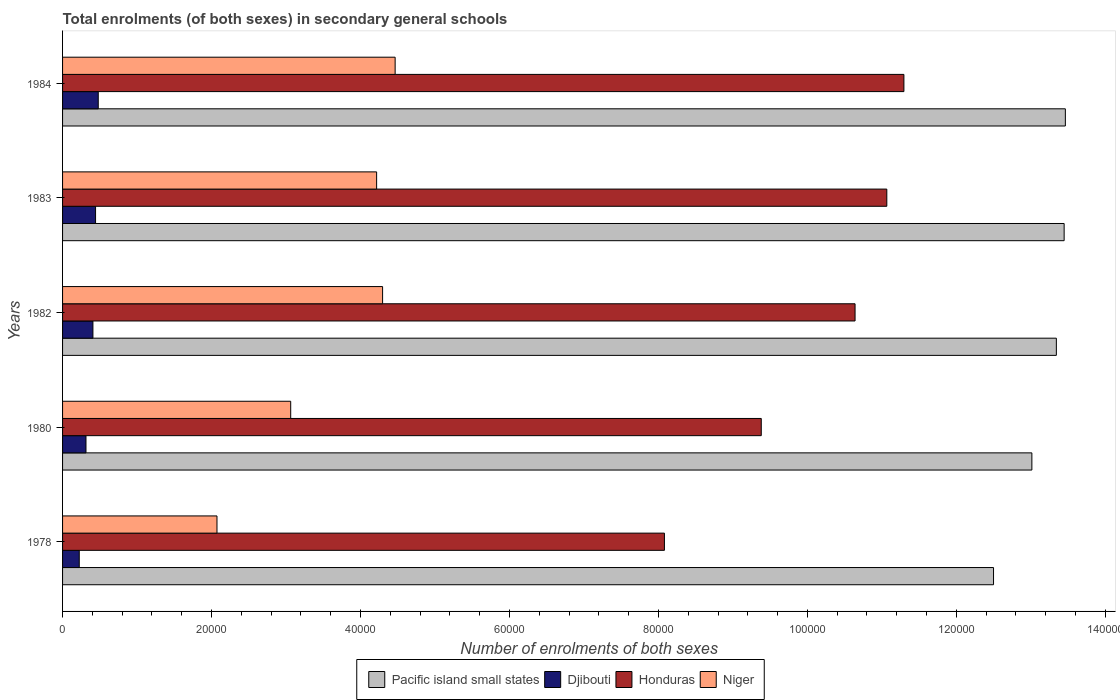How many groups of bars are there?
Provide a short and direct response. 5. What is the label of the 3rd group of bars from the top?
Offer a terse response. 1982. What is the number of enrolments in secondary schools in Niger in 1982?
Your answer should be compact. 4.30e+04. Across all years, what is the maximum number of enrolments in secondary schools in Pacific island small states?
Keep it short and to the point. 1.35e+05. Across all years, what is the minimum number of enrolments in secondary schools in Niger?
Keep it short and to the point. 2.07e+04. In which year was the number of enrolments in secondary schools in Djibouti maximum?
Keep it short and to the point. 1984. In which year was the number of enrolments in secondary schools in Pacific island small states minimum?
Make the answer very short. 1978. What is the total number of enrolments in secondary schools in Pacific island small states in the graph?
Your answer should be very brief. 6.58e+05. What is the difference between the number of enrolments in secondary schools in Niger in 1980 and that in 1984?
Offer a terse response. -1.40e+04. What is the difference between the number of enrolments in secondary schools in Pacific island small states in 1982 and the number of enrolments in secondary schools in Honduras in 1984?
Make the answer very short. 2.05e+04. What is the average number of enrolments in secondary schools in Honduras per year?
Provide a short and direct response. 1.01e+05. In the year 1978, what is the difference between the number of enrolments in secondary schools in Djibouti and number of enrolments in secondary schools in Niger?
Your response must be concise. -1.85e+04. In how many years, is the number of enrolments in secondary schools in Honduras greater than 40000 ?
Offer a very short reply. 5. What is the ratio of the number of enrolments in secondary schools in Djibouti in 1978 to that in 1980?
Ensure brevity in your answer.  0.71. Is the number of enrolments in secondary schools in Djibouti in 1978 less than that in 1984?
Ensure brevity in your answer.  Yes. What is the difference between the highest and the second highest number of enrolments in secondary schools in Djibouti?
Offer a terse response. 362. What is the difference between the highest and the lowest number of enrolments in secondary schools in Djibouti?
Give a very brief answer. 2551. In how many years, is the number of enrolments in secondary schools in Niger greater than the average number of enrolments in secondary schools in Niger taken over all years?
Give a very brief answer. 3. Is it the case that in every year, the sum of the number of enrolments in secondary schools in Djibouti and number of enrolments in secondary schools in Niger is greater than the sum of number of enrolments in secondary schools in Pacific island small states and number of enrolments in secondary schools in Honduras?
Your answer should be very brief. No. What does the 4th bar from the top in 1978 represents?
Provide a short and direct response. Pacific island small states. What does the 3rd bar from the bottom in 1978 represents?
Offer a terse response. Honduras. Is it the case that in every year, the sum of the number of enrolments in secondary schools in Honduras and number of enrolments in secondary schools in Pacific island small states is greater than the number of enrolments in secondary schools in Djibouti?
Provide a short and direct response. Yes. How many years are there in the graph?
Ensure brevity in your answer.  5. What is the difference between two consecutive major ticks on the X-axis?
Keep it short and to the point. 2.00e+04. Are the values on the major ticks of X-axis written in scientific E-notation?
Keep it short and to the point. No. Does the graph contain grids?
Your answer should be compact. No. Where does the legend appear in the graph?
Provide a short and direct response. Bottom center. How many legend labels are there?
Provide a short and direct response. 4. How are the legend labels stacked?
Your answer should be very brief. Horizontal. What is the title of the graph?
Your answer should be very brief. Total enrolments (of both sexes) in secondary general schools. What is the label or title of the X-axis?
Keep it short and to the point. Number of enrolments of both sexes. What is the label or title of the Y-axis?
Make the answer very short. Years. What is the Number of enrolments of both sexes of Pacific island small states in 1978?
Your answer should be very brief. 1.25e+05. What is the Number of enrolments of both sexes in Djibouti in 1978?
Ensure brevity in your answer.  2240. What is the Number of enrolments of both sexes of Honduras in 1978?
Your answer should be compact. 8.08e+04. What is the Number of enrolments of both sexes of Niger in 1978?
Offer a very short reply. 2.07e+04. What is the Number of enrolments of both sexes of Pacific island small states in 1980?
Keep it short and to the point. 1.30e+05. What is the Number of enrolments of both sexes of Djibouti in 1980?
Your answer should be very brief. 3144. What is the Number of enrolments of both sexes in Honduras in 1980?
Provide a succinct answer. 9.38e+04. What is the Number of enrolments of both sexes in Niger in 1980?
Your answer should be very brief. 3.06e+04. What is the Number of enrolments of both sexes of Pacific island small states in 1982?
Your answer should be very brief. 1.33e+05. What is the Number of enrolments of both sexes of Djibouti in 1982?
Offer a terse response. 4076. What is the Number of enrolments of both sexes in Honduras in 1982?
Your response must be concise. 1.06e+05. What is the Number of enrolments of both sexes in Niger in 1982?
Offer a terse response. 4.30e+04. What is the Number of enrolments of both sexes of Pacific island small states in 1983?
Make the answer very short. 1.34e+05. What is the Number of enrolments of both sexes of Djibouti in 1983?
Ensure brevity in your answer.  4429. What is the Number of enrolments of both sexes of Honduras in 1983?
Offer a terse response. 1.11e+05. What is the Number of enrolments of both sexes in Niger in 1983?
Your response must be concise. 4.22e+04. What is the Number of enrolments of both sexes in Pacific island small states in 1984?
Give a very brief answer. 1.35e+05. What is the Number of enrolments of both sexes of Djibouti in 1984?
Your answer should be very brief. 4791. What is the Number of enrolments of both sexes in Honduras in 1984?
Your answer should be compact. 1.13e+05. What is the Number of enrolments of both sexes in Niger in 1984?
Your answer should be compact. 4.46e+04. Across all years, what is the maximum Number of enrolments of both sexes of Pacific island small states?
Keep it short and to the point. 1.35e+05. Across all years, what is the maximum Number of enrolments of both sexes in Djibouti?
Your answer should be very brief. 4791. Across all years, what is the maximum Number of enrolments of both sexes in Honduras?
Provide a succinct answer. 1.13e+05. Across all years, what is the maximum Number of enrolments of both sexes in Niger?
Give a very brief answer. 4.46e+04. Across all years, what is the minimum Number of enrolments of both sexes in Pacific island small states?
Your response must be concise. 1.25e+05. Across all years, what is the minimum Number of enrolments of both sexes of Djibouti?
Provide a short and direct response. 2240. Across all years, what is the minimum Number of enrolments of both sexes in Honduras?
Ensure brevity in your answer.  8.08e+04. Across all years, what is the minimum Number of enrolments of both sexes in Niger?
Your answer should be very brief. 2.07e+04. What is the total Number of enrolments of both sexes of Pacific island small states in the graph?
Make the answer very short. 6.58e+05. What is the total Number of enrolments of both sexes of Djibouti in the graph?
Your answer should be very brief. 1.87e+04. What is the total Number of enrolments of both sexes in Honduras in the graph?
Provide a short and direct response. 5.05e+05. What is the total Number of enrolments of both sexes of Niger in the graph?
Provide a short and direct response. 1.81e+05. What is the difference between the Number of enrolments of both sexes in Pacific island small states in 1978 and that in 1980?
Offer a terse response. -5147.85. What is the difference between the Number of enrolments of both sexes of Djibouti in 1978 and that in 1980?
Your answer should be compact. -904. What is the difference between the Number of enrolments of both sexes of Honduras in 1978 and that in 1980?
Make the answer very short. -1.30e+04. What is the difference between the Number of enrolments of both sexes of Niger in 1978 and that in 1980?
Provide a short and direct response. -9898. What is the difference between the Number of enrolments of both sexes in Pacific island small states in 1978 and that in 1982?
Provide a succinct answer. -8435.27. What is the difference between the Number of enrolments of both sexes of Djibouti in 1978 and that in 1982?
Give a very brief answer. -1836. What is the difference between the Number of enrolments of both sexes of Honduras in 1978 and that in 1982?
Your answer should be compact. -2.56e+04. What is the difference between the Number of enrolments of both sexes of Niger in 1978 and that in 1982?
Keep it short and to the point. -2.22e+04. What is the difference between the Number of enrolments of both sexes in Pacific island small states in 1978 and that in 1983?
Provide a short and direct response. -9479.97. What is the difference between the Number of enrolments of both sexes of Djibouti in 1978 and that in 1983?
Provide a short and direct response. -2189. What is the difference between the Number of enrolments of both sexes of Honduras in 1978 and that in 1983?
Keep it short and to the point. -2.99e+04. What is the difference between the Number of enrolments of both sexes in Niger in 1978 and that in 1983?
Provide a short and direct response. -2.14e+04. What is the difference between the Number of enrolments of both sexes of Pacific island small states in 1978 and that in 1984?
Keep it short and to the point. -9641.75. What is the difference between the Number of enrolments of both sexes of Djibouti in 1978 and that in 1984?
Provide a succinct answer. -2551. What is the difference between the Number of enrolments of both sexes in Honduras in 1978 and that in 1984?
Your answer should be compact. -3.22e+04. What is the difference between the Number of enrolments of both sexes in Niger in 1978 and that in 1984?
Provide a succinct answer. -2.39e+04. What is the difference between the Number of enrolments of both sexes of Pacific island small states in 1980 and that in 1982?
Keep it short and to the point. -3287.41. What is the difference between the Number of enrolments of both sexes of Djibouti in 1980 and that in 1982?
Offer a terse response. -932. What is the difference between the Number of enrolments of both sexes of Honduras in 1980 and that in 1982?
Make the answer very short. -1.26e+04. What is the difference between the Number of enrolments of both sexes in Niger in 1980 and that in 1982?
Make the answer very short. -1.23e+04. What is the difference between the Number of enrolments of both sexes of Pacific island small states in 1980 and that in 1983?
Your response must be concise. -4332.12. What is the difference between the Number of enrolments of both sexes of Djibouti in 1980 and that in 1983?
Offer a terse response. -1285. What is the difference between the Number of enrolments of both sexes in Honduras in 1980 and that in 1983?
Ensure brevity in your answer.  -1.69e+04. What is the difference between the Number of enrolments of both sexes in Niger in 1980 and that in 1983?
Ensure brevity in your answer.  -1.15e+04. What is the difference between the Number of enrolments of both sexes of Pacific island small states in 1980 and that in 1984?
Keep it short and to the point. -4493.9. What is the difference between the Number of enrolments of both sexes of Djibouti in 1980 and that in 1984?
Offer a very short reply. -1647. What is the difference between the Number of enrolments of both sexes of Honduras in 1980 and that in 1984?
Provide a short and direct response. -1.92e+04. What is the difference between the Number of enrolments of both sexes of Niger in 1980 and that in 1984?
Keep it short and to the point. -1.40e+04. What is the difference between the Number of enrolments of both sexes of Pacific island small states in 1982 and that in 1983?
Provide a succinct answer. -1044.7. What is the difference between the Number of enrolments of both sexes of Djibouti in 1982 and that in 1983?
Your answer should be compact. -353. What is the difference between the Number of enrolments of both sexes of Honduras in 1982 and that in 1983?
Your answer should be compact. -4263. What is the difference between the Number of enrolments of both sexes in Niger in 1982 and that in 1983?
Keep it short and to the point. 803. What is the difference between the Number of enrolments of both sexes of Pacific island small states in 1982 and that in 1984?
Provide a succinct answer. -1206.48. What is the difference between the Number of enrolments of both sexes in Djibouti in 1982 and that in 1984?
Provide a short and direct response. -715. What is the difference between the Number of enrolments of both sexes in Honduras in 1982 and that in 1984?
Give a very brief answer. -6558. What is the difference between the Number of enrolments of both sexes in Niger in 1982 and that in 1984?
Offer a very short reply. -1683. What is the difference between the Number of enrolments of both sexes of Pacific island small states in 1983 and that in 1984?
Provide a succinct answer. -161.78. What is the difference between the Number of enrolments of both sexes in Djibouti in 1983 and that in 1984?
Your answer should be compact. -362. What is the difference between the Number of enrolments of both sexes of Honduras in 1983 and that in 1984?
Provide a succinct answer. -2295. What is the difference between the Number of enrolments of both sexes in Niger in 1983 and that in 1984?
Offer a very short reply. -2486. What is the difference between the Number of enrolments of both sexes in Pacific island small states in 1978 and the Number of enrolments of both sexes in Djibouti in 1980?
Your response must be concise. 1.22e+05. What is the difference between the Number of enrolments of both sexes of Pacific island small states in 1978 and the Number of enrolments of both sexes of Honduras in 1980?
Your answer should be compact. 3.12e+04. What is the difference between the Number of enrolments of both sexes in Pacific island small states in 1978 and the Number of enrolments of both sexes in Niger in 1980?
Provide a short and direct response. 9.44e+04. What is the difference between the Number of enrolments of both sexes of Djibouti in 1978 and the Number of enrolments of both sexes of Honduras in 1980?
Offer a terse response. -9.16e+04. What is the difference between the Number of enrolments of both sexes of Djibouti in 1978 and the Number of enrolments of both sexes of Niger in 1980?
Offer a very short reply. -2.84e+04. What is the difference between the Number of enrolments of both sexes of Honduras in 1978 and the Number of enrolments of both sexes of Niger in 1980?
Your answer should be very brief. 5.02e+04. What is the difference between the Number of enrolments of both sexes in Pacific island small states in 1978 and the Number of enrolments of both sexes in Djibouti in 1982?
Your answer should be compact. 1.21e+05. What is the difference between the Number of enrolments of both sexes of Pacific island small states in 1978 and the Number of enrolments of both sexes of Honduras in 1982?
Provide a succinct answer. 1.86e+04. What is the difference between the Number of enrolments of both sexes in Pacific island small states in 1978 and the Number of enrolments of both sexes in Niger in 1982?
Your answer should be very brief. 8.20e+04. What is the difference between the Number of enrolments of both sexes of Djibouti in 1978 and the Number of enrolments of both sexes of Honduras in 1982?
Your response must be concise. -1.04e+05. What is the difference between the Number of enrolments of both sexes of Djibouti in 1978 and the Number of enrolments of both sexes of Niger in 1982?
Make the answer very short. -4.07e+04. What is the difference between the Number of enrolments of both sexes in Honduras in 1978 and the Number of enrolments of both sexes in Niger in 1982?
Ensure brevity in your answer.  3.78e+04. What is the difference between the Number of enrolments of both sexes in Pacific island small states in 1978 and the Number of enrolments of both sexes in Djibouti in 1983?
Ensure brevity in your answer.  1.21e+05. What is the difference between the Number of enrolments of both sexes in Pacific island small states in 1978 and the Number of enrolments of both sexes in Honduras in 1983?
Your answer should be compact. 1.43e+04. What is the difference between the Number of enrolments of both sexes in Pacific island small states in 1978 and the Number of enrolments of both sexes in Niger in 1983?
Ensure brevity in your answer.  8.28e+04. What is the difference between the Number of enrolments of both sexes of Djibouti in 1978 and the Number of enrolments of both sexes of Honduras in 1983?
Give a very brief answer. -1.08e+05. What is the difference between the Number of enrolments of both sexes of Djibouti in 1978 and the Number of enrolments of both sexes of Niger in 1983?
Give a very brief answer. -3.99e+04. What is the difference between the Number of enrolments of both sexes of Honduras in 1978 and the Number of enrolments of both sexes of Niger in 1983?
Your answer should be very brief. 3.86e+04. What is the difference between the Number of enrolments of both sexes in Pacific island small states in 1978 and the Number of enrolments of both sexes in Djibouti in 1984?
Your answer should be very brief. 1.20e+05. What is the difference between the Number of enrolments of both sexes of Pacific island small states in 1978 and the Number of enrolments of both sexes of Honduras in 1984?
Ensure brevity in your answer.  1.20e+04. What is the difference between the Number of enrolments of both sexes in Pacific island small states in 1978 and the Number of enrolments of both sexes in Niger in 1984?
Ensure brevity in your answer.  8.03e+04. What is the difference between the Number of enrolments of both sexes in Djibouti in 1978 and the Number of enrolments of both sexes in Honduras in 1984?
Offer a terse response. -1.11e+05. What is the difference between the Number of enrolments of both sexes in Djibouti in 1978 and the Number of enrolments of both sexes in Niger in 1984?
Keep it short and to the point. -4.24e+04. What is the difference between the Number of enrolments of both sexes in Honduras in 1978 and the Number of enrolments of both sexes in Niger in 1984?
Offer a terse response. 3.62e+04. What is the difference between the Number of enrolments of both sexes in Pacific island small states in 1980 and the Number of enrolments of both sexes in Djibouti in 1982?
Provide a short and direct response. 1.26e+05. What is the difference between the Number of enrolments of both sexes of Pacific island small states in 1980 and the Number of enrolments of both sexes of Honduras in 1982?
Keep it short and to the point. 2.37e+04. What is the difference between the Number of enrolments of both sexes of Pacific island small states in 1980 and the Number of enrolments of both sexes of Niger in 1982?
Ensure brevity in your answer.  8.72e+04. What is the difference between the Number of enrolments of both sexes of Djibouti in 1980 and the Number of enrolments of both sexes of Honduras in 1982?
Keep it short and to the point. -1.03e+05. What is the difference between the Number of enrolments of both sexes in Djibouti in 1980 and the Number of enrolments of both sexes in Niger in 1982?
Give a very brief answer. -3.98e+04. What is the difference between the Number of enrolments of both sexes of Honduras in 1980 and the Number of enrolments of both sexes of Niger in 1982?
Provide a short and direct response. 5.08e+04. What is the difference between the Number of enrolments of both sexes of Pacific island small states in 1980 and the Number of enrolments of both sexes of Djibouti in 1983?
Your answer should be very brief. 1.26e+05. What is the difference between the Number of enrolments of both sexes in Pacific island small states in 1980 and the Number of enrolments of both sexes in Honduras in 1983?
Your response must be concise. 1.95e+04. What is the difference between the Number of enrolments of both sexes in Pacific island small states in 1980 and the Number of enrolments of both sexes in Niger in 1983?
Give a very brief answer. 8.80e+04. What is the difference between the Number of enrolments of both sexes in Djibouti in 1980 and the Number of enrolments of both sexes in Honduras in 1983?
Your answer should be compact. -1.08e+05. What is the difference between the Number of enrolments of both sexes of Djibouti in 1980 and the Number of enrolments of both sexes of Niger in 1983?
Offer a terse response. -3.90e+04. What is the difference between the Number of enrolments of both sexes in Honduras in 1980 and the Number of enrolments of both sexes in Niger in 1983?
Make the answer very short. 5.16e+04. What is the difference between the Number of enrolments of both sexes in Pacific island small states in 1980 and the Number of enrolments of both sexes in Djibouti in 1984?
Offer a terse response. 1.25e+05. What is the difference between the Number of enrolments of both sexes of Pacific island small states in 1980 and the Number of enrolments of both sexes of Honduras in 1984?
Ensure brevity in your answer.  1.72e+04. What is the difference between the Number of enrolments of both sexes in Pacific island small states in 1980 and the Number of enrolments of both sexes in Niger in 1984?
Offer a terse response. 8.55e+04. What is the difference between the Number of enrolments of both sexes in Djibouti in 1980 and the Number of enrolments of both sexes in Honduras in 1984?
Provide a succinct answer. -1.10e+05. What is the difference between the Number of enrolments of both sexes in Djibouti in 1980 and the Number of enrolments of both sexes in Niger in 1984?
Offer a terse response. -4.15e+04. What is the difference between the Number of enrolments of both sexes in Honduras in 1980 and the Number of enrolments of both sexes in Niger in 1984?
Your answer should be very brief. 4.92e+04. What is the difference between the Number of enrolments of both sexes in Pacific island small states in 1982 and the Number of enrolments of both sexes in Djibouti in 1983?
Provide a short and direct response. 1.29e+05. What is the difference between the Number of enrolments of both sexes of Pacific island small states in 1982 and the Number of enrolments of both sexes of Honduras in 1983?
Provide a succinct answer. 2.28e+04. What is the difference between the Number of enrolments of both sexes in Pacific island small states in 1982 and the Number of enrolments of both sexes in Niger in 1983?
Offer a terse response. 9.13e+04. What is the difference between the Number of enrolments of both sexes of Djibouti in 1982 and the Number of enrolments of both sexes of Honduras in 1983?
Offer a very short reply. -1.07e+05. What is the difference between the Number of enrolments of both sexes in Djibouti in 1982 and the Number of enrolments of both sexes in Niger in 1983?
Make the answer very short. -3.81e+04. What is the difference between the Number of enrolments of both sexes of Honduras in 1982 and the Number of enrolments of both sexes of Niger in 1983?
Ensure brevity in your answer.  6.42e+04. What is the difference between the Number of enrolments of both sexes of Pacific island small states in 1982 and the Number of enrolments of both sexes of Djibouti in 1984?
Your answer should be very brief. 1.29e+05. What is the difference between the Number of enrolments of both sexes of Pacific island small states in 1982 and the Number of enrolments of both sexes of Honduras in 1984?
Provide a succinct answer. 2.05e+04. What is the difference between the Number of enrolments of both sexes of Pacific island small states in 1982 and the Number of enrolments of both sexes of Niger in 1984?
Keep it short and to the point. 8.88e+04. What is the difference between the Number of enrolments of both sexes in Djibouti in 1982 and the Number of enrolments of both sexes in Honduras in 1984?
Make the answer very short. -1.09e+05. What is the difference between the Number of enrolments of both sexes of Djibouti in 1982 and the Number of enrolments of both sexes of Niger in 1984?
Give a very brief answer. -4.06e+04. What is the difference between the Number of enrolments of both sexes of Honduras in 1982 and the Number of enrolments of both sexes of Niger in 1984?
Your answer should be compact. 6.17e+04. What is the difference between the Number of enrolments of both sexes in Pacific island small states in 1983 and the Number of enrolments of both sexes in Djibouti in 1984?
Provide a succinct answer. 1.30e+05. What is the difference between the Number of enrolments of both sexes in Pacific island small states in 1983 and the Number of enrolments of both sexes in Honduras in 1984?
Give a very brief answer. 2.15e+04. What is the difference between the Number of enrolments of both sexes of Pacific island small states in 1983 and the Number of enrolments of both sexes of Niger in 1984?
Make the answer very short. 8.98e+04. What is the difference between the Number of enrolments of both sexes in Djibouti in 1983 and the Number of enrolments of both sexes in Honduras in 1984?
Your answer should be very brief. -1.09e+05. What is the difference between the Number of enrolments of both sexes in Djibouti in 1983 and the Number of enrolments of both sexes in Niger in 1984?
Offer a terse response. -4.02e+04. What is the difference between the Number of enrolments of both sexes in Honduras in 1983 and the Number of enrolments of both sexes in Niger in 1984?
Offer a terse response. 6.60e+04. What is the average Number of enrolments of both sexes of Pacific island small states per year?
Your answer should be compact. 1.32e+05. What is the average Number of enrolments of both sexes of Djibouti per year?
Make the answer very short. 3736. What is the average Number of enrolments of both sexes of Honduras per year?
Your answer should be very brief. 1.01e+05. What is the average Number of enrolments of both sexes of Niger per year?
Offer a very short reply. 3.62e+04. In the year 1978, what is the difference between the Number of enrolments of both sexes in Pacific island small states and Number of enrolments of both sexes in Djibouti?
Make the answer very short. 1.23e+05. In the year 1978, what is the difference between the Number of enrolments of both sexes of Pacific island small states and Number of enrolments of both sexes of Honduras?
Ensure brevity in your answer.  4.42e+04. In the year 1978, what is the difference between the Number of enrolments of both sexes in Pacific island small states and Number of enrolments of both sexes in Niger?
Your answer should be very brief. 1.04e+05. In the year 1978, what is the difference between the Number of enrolments of both sexes of Djibouti and Number of enrolments of both sexes of Honduras?
Provide a short and direct response. -7.86e+04. In the year 1978, what is the difference between the Number of enrolments of both sexes in Djibouti and Number of enrolments of both sexes in Niger?
Ensure brevity in your answer.  -1.85e+04. In the year 1978, what is the difference between the Number of enrolments of both sexes of Honduras and Number of enrolments of both sexes of Niger?
Your response must be concise. 6.01e+04. In the year 1980, what is the difference between the Number of enrolments of both sexes of Pacific island small states and Number of enrolments of both sexes of Djibouti?
Offer a terse response. 1.27e+05. In the year 1980, what is the difference between the Number of enrolments of both sexes of Pacific island small states and Number of enrolments of both sexes of Honduras?
Make the answer very short. 3.63e+04. In the year 1980, what is the difference between the Number of enrolments of both sexes of Pacific island small states and Number of enrolments of both sexes of Niger?
Offer a very short reply. 9.95e+04. In the year 1980, what is the difference between the Number of enrolments of both sexes of Djibouti and Number of enrolments of both sexes of Honduras?
Provide a short and direct response. -9.07e+04. In the year 1980, what is the difference between the Number of enrolments of both sexes of Djibouti and Number of enrolments of both sexes of Niger?
Provide a short and direct response. -2.75e+04. In the year 1980, what is the difference between the Number of enrolments of both sexes of Honduras and Number of enrolments of both sexes of Niger?
Provide a succinct answer. 6.32e+04. In the year 1982, what is the difference between the Number of enrolments of both sexes in Pacific island small states and Number of enrolments of both sexes in Djibouti?
Offer a terse response. 1.29e+05. In the year 1982, what is the difference between the Number of enrolments of both sexes of Pacific island small states and Number of enrolments of both sexes of Honduras?
Your answer should be very brief. 2.70e+04. In the year 1982, what is the difference between the Number of enrolments of both sexes of Pacific island small states and Number of enrolments of both sexes of Niger?
Give a very brief answer. 9.05e+04. In the year 1982, what is the difference between the Number of enrolments of both sexes of Djibouti and Number of enrolments of both sexes of Honduras?
Offer a terse response. -1.02e+05. In the year 1982, what is the difference between the Number of enrolments of both sexes of Djibouti and Number of enrolments of both sexes of Niger?
Offer a very short reply. -3.89e+04. In the year 1982, what is the difference between the Number of enrolments of both sexes of Honduras and Number of enrolments of both sexes of Niger?
Offer a very short reply. 6.34e+04. In the year 1983, what is the difference between the Number of enrolments of both sexes of Pacific island small states and Number of enrolments of both sexes of Djibouti?
Your answer should be compact. 1.30e+05. In the year 1983, what is the difference between the Number of enrolments of both sexes in Pacific island small states and Number of enrolments of both sexes in Honduras?
Offer a very short reply. 2.38e+04. In the year 1983, what is the difference between the Number of enrolments of both sexes of Pacific island small states and Number of enrolments of both sexes of Niger?
Your answer should be compact. 9.23e+04. In the year 1983, what is the difference between the Number of enrolments of both sexes in Djibouti and Number of enrolments of both sexes in Honduras?
Provide a succinct answer. -1.06e+05. In the year 1983, what is the difference between the Number of enrolments of both sexes of Djibouti and Number of enrolments of both sexes of Niger?
Provide a short and direct response. -3.77e+04. In the year 1983, what is the difference between the Number of enrolments of both sexes of Honduras and Number of enrolments of both sexes of Niger?
Provide a succinct answer. 6.85e+04. In the year 1984, what is the difference between the Number of enrolments of both sexes of Pacific island small states and Number of enrolments of both sexes of Djibouti?
Offer a terse response. 1.30e+05. In the year 1984, what is the difference between the Number of enrolments of both sexes of Pacific island small states and Number of enrolments of both sexes of Honduras?
Your answer should be very brief. 2.17e+04. In the year 1984, what is the difference between the Number of enrolments of both sexes in Pacific island small states and Number of enrolments of both sexes in Niger?
Ensure brevity in your answer.  9.00e+04. In the year 1984, what is the difference between the Number of enrolments of both sexes in Djibouti and Number of enrolments of both sexes in Honduras?
Your answer should be compact. -1.08e+05. In the year 1984, what is the difference between the Number of enrolments of both sexes of Djibouti and Number of enrolments of both sexes of Niger?
Your answer should be compact. -3.99e+04. In the year 1984, what is the difference between the Number of enrolments of both sexes of Honduras and Number of enrolments of both sexes of Niger?
Offer a very short reply. 6.83e+04. What is the ratio of the Number of enrolments of both sexes of Pacific island small states in 1978 to that in 1980?
Your response must be concise. 0.96. What is the ratio of the Number of enrolments of both sexes in Djibouti in 1978 to that in 1980?
Keep it short and to the point. 0.71. What is the ratio of the Number of enrolments of both sexes in Honduras in 1978 to that in 1980?
Keep it short and to the point. 0.86. What is the ratio of the Number of enrolments of both sexes in Niger in 1978 to that in 1980?
Your response must be concise. 0.68. What is the ratio of the Number of enrolments of both sexes of Pacific island small states in 1978 to that in 1982?
Your answer should be compact. 0.94. What is the ratio of the Number of enrolments of both sexes of Djibouti in 1978 to that in 1982?
Your answer should be very brief. 0.55. What is the ratio of the Number of enrolments of both sexes in Honduras in 1978 to that in 1982?
Provide a succinct answer. 0.76. What is the ratio of the Number of enrolments of both sexes in Niger in 1978 to that in 1982?
Your answer should be compact. 0.48. What is the ratio of the Number of enrolments of both sexes in Pacific island small states in 1978 to that in 1983?
Offer a very short reply. 0.93. What is the ratio of the Number of enrolments of both sexes of Djibouti in 1978 to that in 1983?
Your response must be concise. 0.51. What is the ratio of the Number of enrolments of both sexes in Honduras in 1978 to that in 1983?
Ensure brevity in your answer.  0.73. What is the ratio of the Number of enrolments of both sexes in Niger in 1978 to that in 1983?
Your response must be concise. 0.49. What is the ratio of the Number of enrolments of both sexes of Pacific island small states in 1978 to that in 1984?
Make the answer very short. 0.93. What is the ratio of the Number of enrolments of both sexes in Djibouti in 1978 to that in 1984?
Your response must be concise. 0.47. What is the ratio of the Number of enrolments of both sexes of Honduras in 1978 to that in 1984?
Offer a terse response. 0.72. What is the ratio of the Number of enrolments of both sexes of Niger in 1978 to that in 1984?
Offer a terse response. 0.46. What is the ratio of the Number of enrolments of both sexes in Pacific island small states in 1980 to that in 1982?
Give a very brief answer. 0.98. What is the ratio of the Number of enrolments of both sexes in Djibouti in 1980 to that in 1982?
Your answer should be very brief. 0.77. What is the ratio of the Number of enrolments of both sexes of Honduras in 1980 to that in 1982?
Provide a succinct answer. 0.88. What is the ratio of the Number of enrolments of both sexes in Niger in 1980 to that in 1982?
Your answer should be compact. 0.71. What is the ratio of the Number of enrolments of both sexes in Pacific island small states in 1980 to that in 1983?
Provide a succinct answer. 0.97. What is the ratio of the Number of enrolments of both sexes in Djibouti in 1980 to that in 1983?
Ensure brevity in your answer.  0.71. What is the ratio of the Number of enrolments of both sexes in Honduras in 1980 to that in 1983?
Offer a very short reply. 0.85. What is the ratio of the Number of enrolments of both sexes in Niger in 1980 to that in 1983?
Provide a short and direct response. 0.73. What is the ratio of the Number of enrolments of both sexes in Pacific island small states in 1980 to that in 1984?
Offer a very short reply. 0.97. What is the ratio of the Number of enrolments of both sexes of Djibouti in 1980 to that in 1984?
Provide a succinct answer. 0.66. What is the ratio of the Number of enrolments of both sexes of Honduras in 1980 to that in 1984?
Provide a short and direct response. 0.83. What is the ratio of the Number of enrolments of both sexes of Niger in 1980 to that in 1984?
Provide a succinct answer. 0.69. What is the ratio of the Number of enrolments of both sexes of Pacific island small states in 1982 to that in 1983?
Keep it short and to the point. 0.99. What is the ratio of the Number of enrolments of both sexes of Djibouti in 1982 to that in 1983?
Provide a succinct answer. 0.92. What is the ratio of the Number of enrolments of both sexes in Honduras in 1982 to that in 1983?
Give a very brief answer. 0.96. What is the ratio of the Number of enrolments of both sexes in Niger in 1982 to that in 1983?
Ensure brevity in your answer.  1.02. What is the ratio of the Number of enrolments of both sexes in Djibouti in 1982 to that in 1984?
Keep it short and to the point. 0.85. What is the ratio of the Number of enrolments of both sexes of Honduras in 1982 to that in 1984?
Keep it short and to the point. 0.94. What is the ratio of the Number of enrolments of both sexes of Niger in 1982 to that in 1984?
Offer a very short reply. 0.96. What is the ratio of the Number of enrolments of both sexes of Djibouti in 1983 to that in 1984?
Keep it short and to the point. 0.92. What is the ratio of the Number of enrolments of both sexes in Honduras in 1983 to that in 1984?
Your answer should be very brief. 0.98. What is the ratio of the Number of enrolments of both sexes of Niger in 1983 to that in 1984?
Your response must be concise. 0.94. What is the difference between the highest and the second highest Number of enrolments of both sexes of Pacific island small states?
Make the answer very short. 161.78. What is the difference between the highest and the second highest Number of enrolments of both sexes in Djibouti?
Your answer should be compact. 362. What is the difference between the highest and the second highest Number of enrolments of both sexes in Honduras?
Provide a succinct answer. 2295. What is the difference between the highest and the second highest Number of enrolments of both sexes of Niger?
Ensure brevity in your answer.  1683. What is the difference between the highest and the lowest Number of enrolments of both sexes in Pacific island small states?
Make the answer very short. 9641.75. What is the difference between the highest and the lowest Number of enrolments of both sexes in Djibouti?
Your answer should be compact. 2551. What is the difference between the highest and the lowest Number of enrolments of both sexes in Honduras?
Your answer should be compact. 3.22e+04. What is the difference between the highest and the lowest Number of enrolments of both sexes of Niger?
Keep it short and to the point. 2.39e+04. 